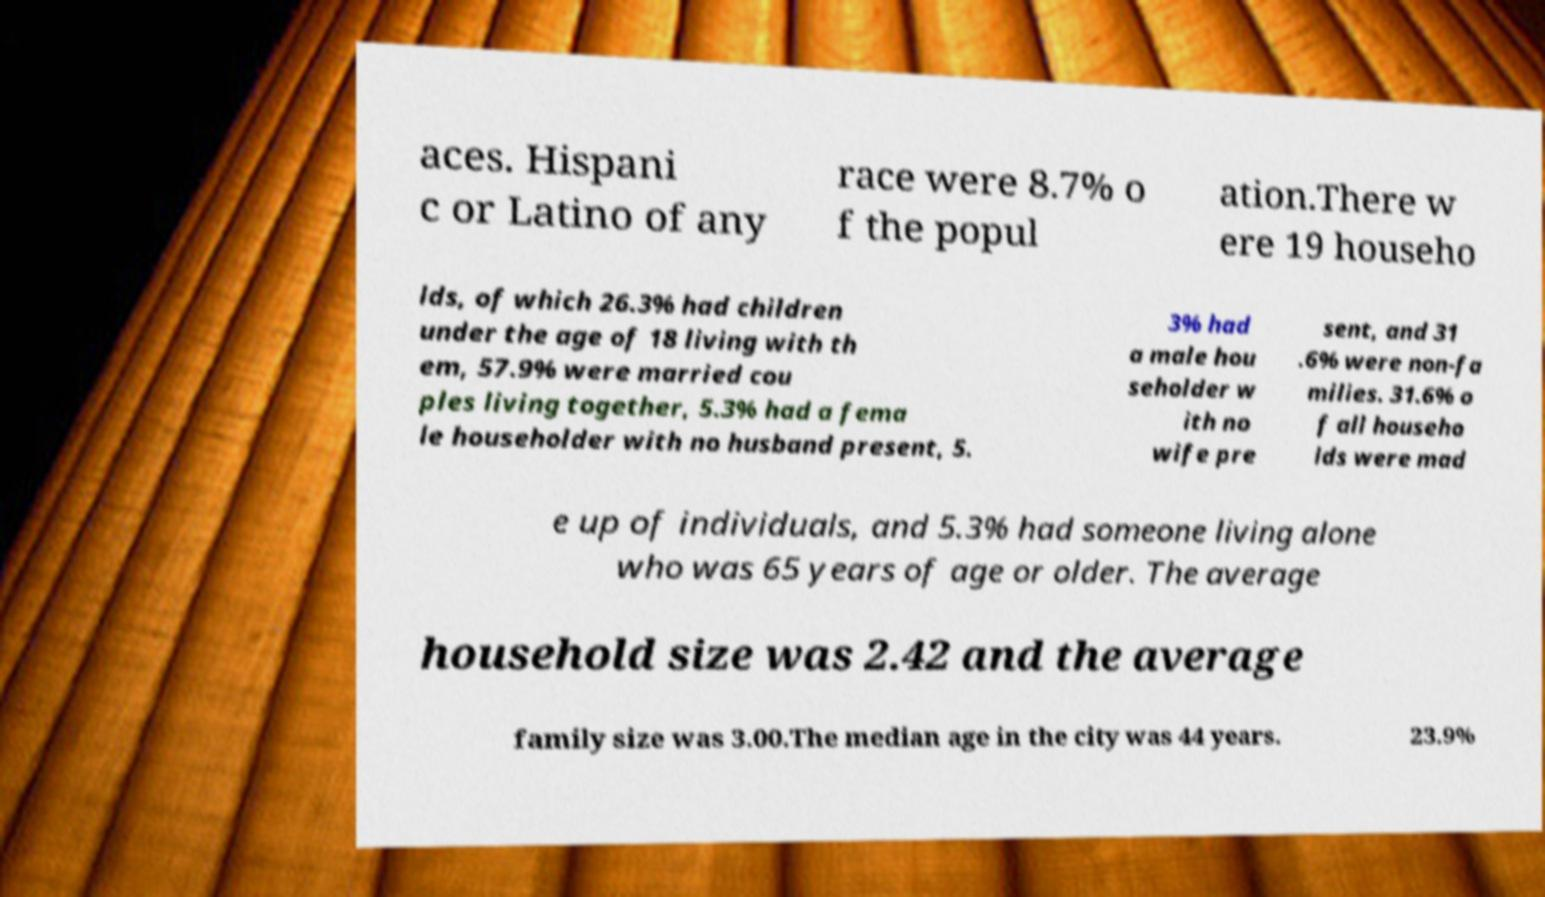There's text embedded in this image that I need extracted. Can you transcribe it verbatim? aces. Hispani c or Latino of any race were 8.7% o f the popul ation.There w ere 19 househo lds, of which 26.3% had children under the age of 18 living with th em, 57.9% were married cou ples living together, 5.3% had a fema le householder with no husband present, 5. 3% had a male hou seholder w ith no wife pre sent, and 31 .6% were non-fa milies. 31.6% o f all househo lds were mad e up of individuals, and 5.3% had someone living alone who was 65 years of age or older. The average household size was 2.42 and the average family size was 3.00.The median age in the city was 44 years. 23.9% 